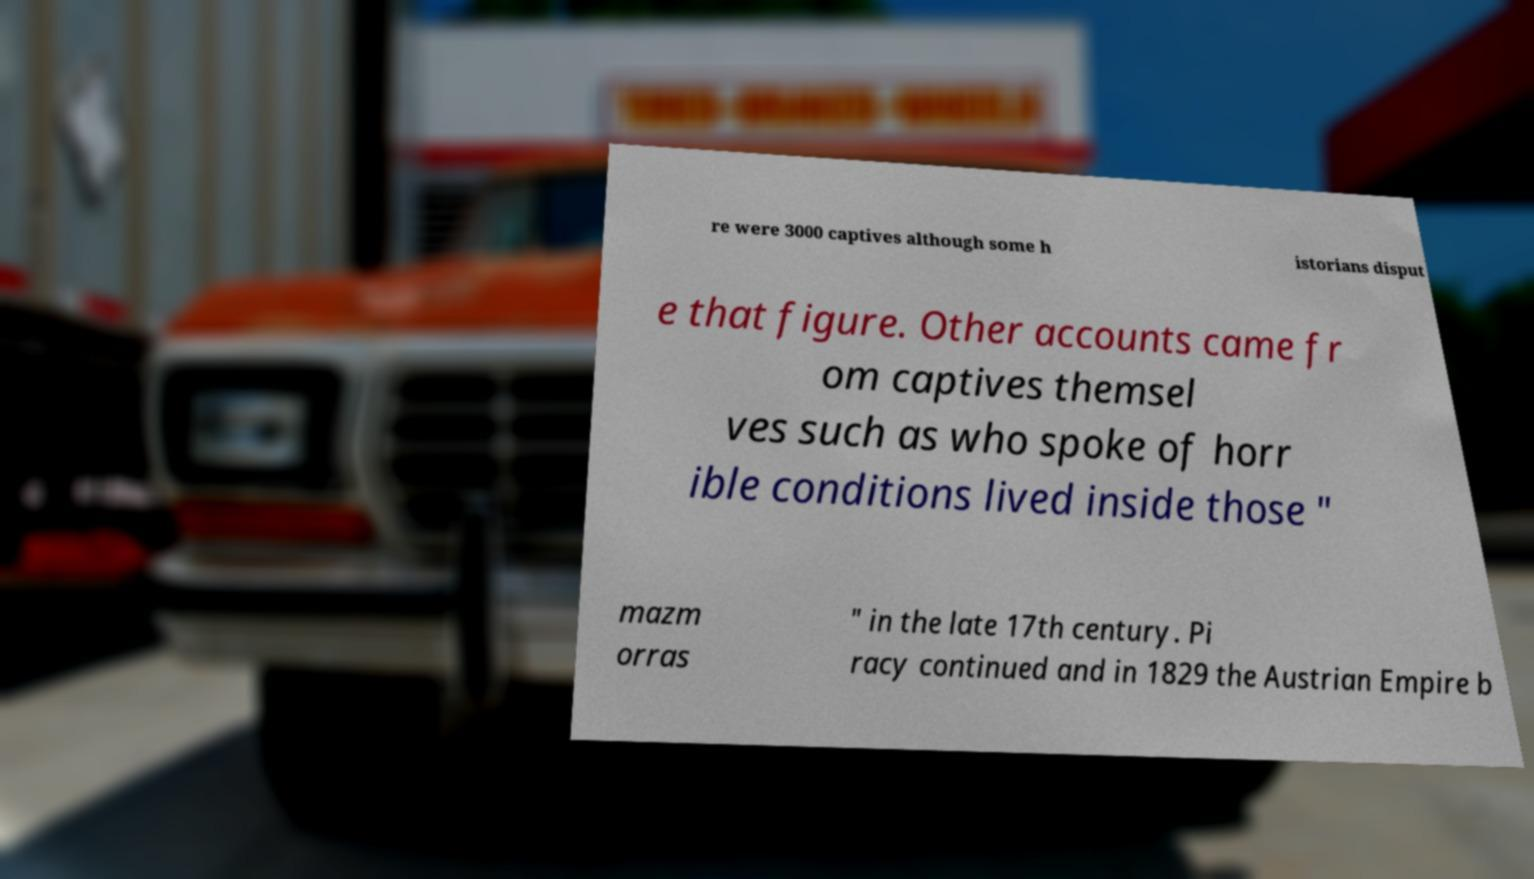Could you extract and type out the text from this image? re were 3000 captives although some h istorians disput e that figure. Other accounts came fr om captives themsel ves such as who spoke of horr ible conditions lived inside those " mazm orras " in the late 17th century. Pi racy continued and in 1829 the Austrian Empire b 